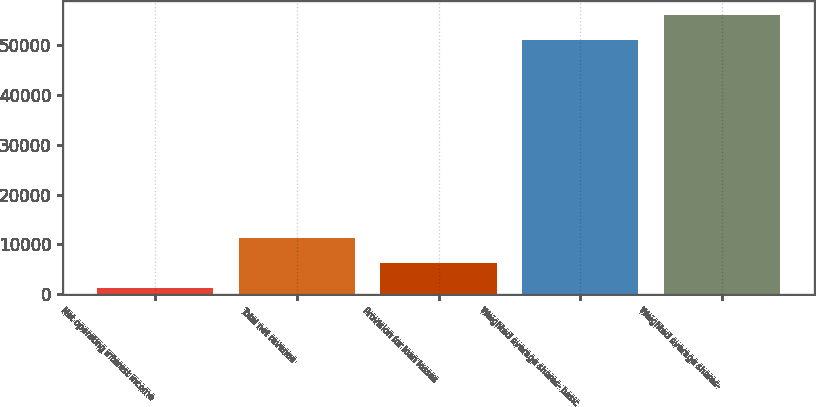Convert chart. <chart><loc_0><loc_0><loc_500><loc_500><bar_chart><fcel>Net operating interest income<fcel>Total net revenue<fcel>Provision for loan losses<fcel>Weighted average shares- basic<fcel>Weighted average shares-<nl><fcel>1268<fcel>11211.6<fcel>6239.8<fcel>50986<fcel>55957.8<nl></chart> 